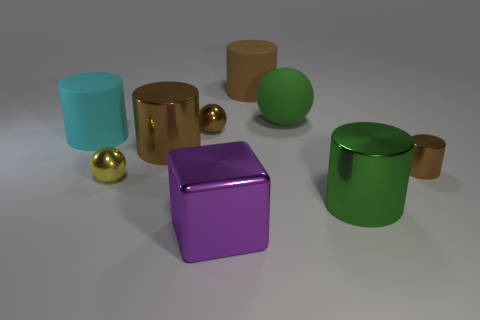Subtract all green blocks. How many brown cylinders are left? 3 Add 1 matte spheres. How many objects exist? 10 Subtract 2 cylinders. How many cylinders are left? 3 Subtract all cyan cylinders. How many cylinders are left? 4 Subtract all cyan cylinders. How many cylinders are left? 4 Subtract all spheres. How many objects are left? 6 Subtract all cyan cylinders. Subtract all cyan cubes. How many cylinders are left? 4 Add 8 small yellow objects. How many small yellow objects are left? 9 Add 6 brown balls. How many brown balls exist? 7 Subtract 0 green cubes. How many objects are left? 9 